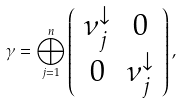<formula> <loc_0><loc_0><loc_500><loc_500>\gamma = \bigoplus _ { j = 1 } ^ { n } \left ( \begin{array} { c c } \nu _ { j } ^ { \downarrow } & 0 \\ 0 & \nu _ { j } ^ { \downarrow } \end{array} \right ) ,</formula> 